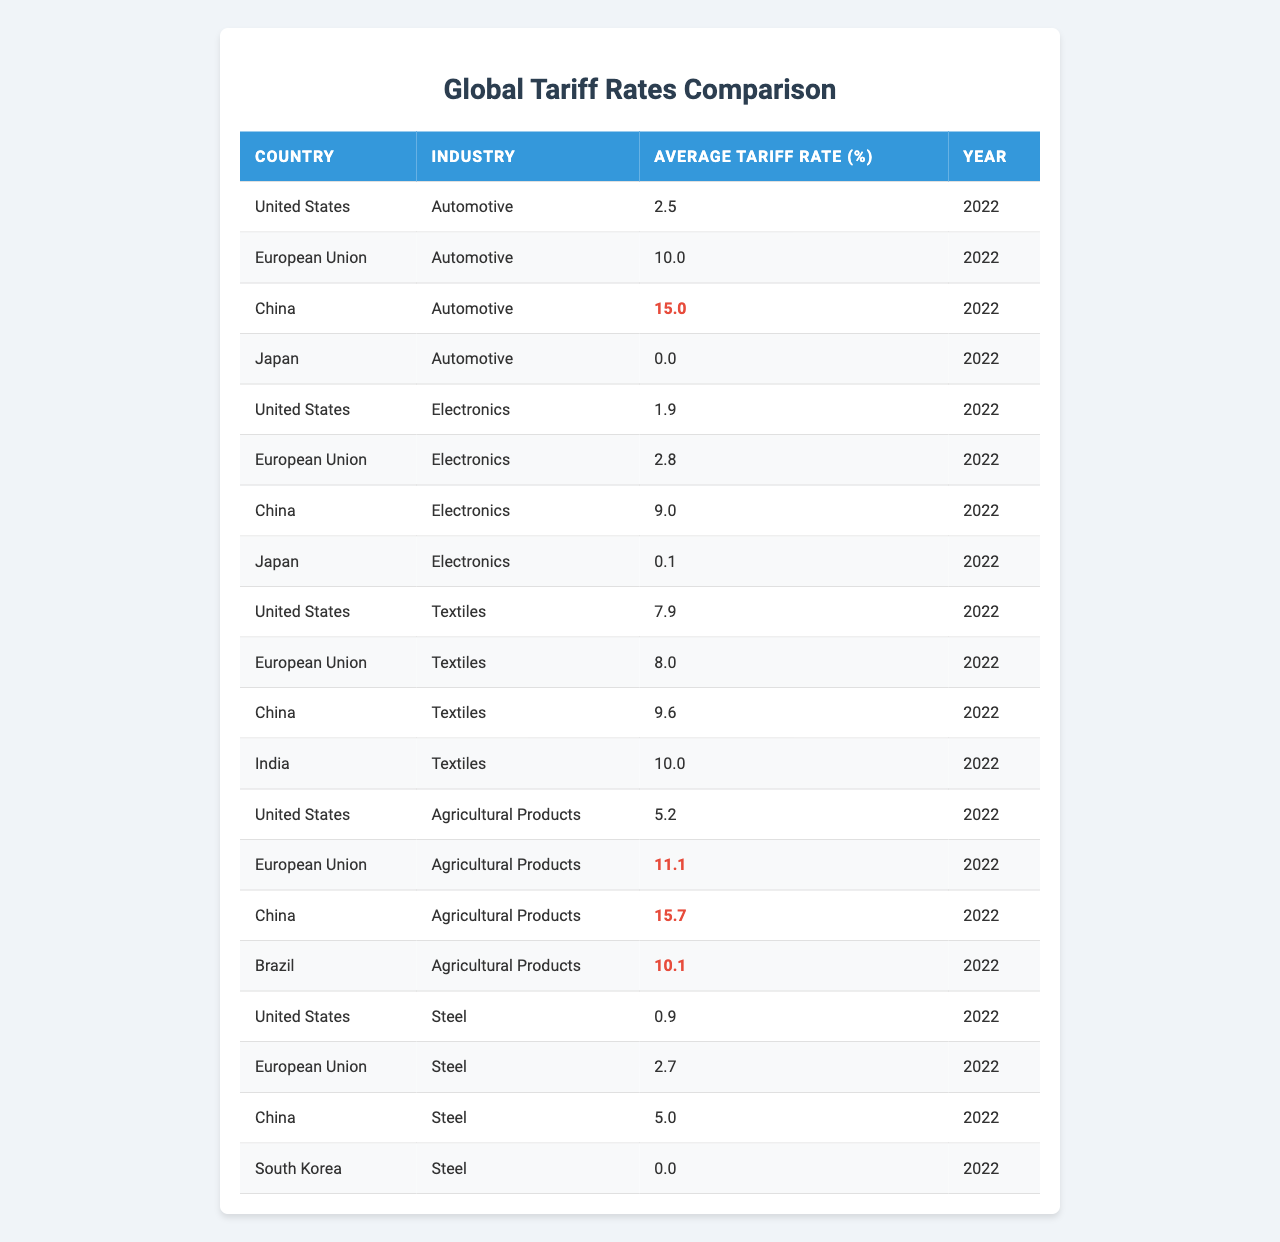What is the average tariff rate for automotive industry across these countries? The average tariff rates for the automotive industry are 2.5% (USA), 10.0% (EU), 15.0% (China), and 0.0% (Japan). To calculate the average, sum these rates: 2.5 + 10.0 + 15.0 + 0.0 = 27.5%. Divide by 4 (number of countries), resulting in an average of 27.5% / 4 = 6.875%.
Answer: 6.875% Which country has the highest tariff rate for electronics? Looking at the tariff rates for electronics, we have 1.9% (USA), 2.8% (EU), 9.0% (China), and 0.1% (Japan). The highest value here is 9.0% from China.
Answer: China Do any countries have a tariff rate of 0% for the steel industry? In the table, the tariff rates for steel are as follows: 0.9% (USA), 2.7% (EU), 5.0% (China), and 0.0% (South Korea). Since South Korea has a rate of 0.0%, the answer is yes.
Answer: Yes What is the difference in the average tariff rate for agricultural products between the EU and China? The average tariff rates for agricultural products are 11.1% (EU) and 15.7% (China). To find the difference, subtract the EU rate from the China rate: 15.7 - 11.1 = 4.6.
Answer: 4.6% Is the average tariff rate for textiles higher in the US than in Japan? The average tariff rates for textiles are 7.9% (USA) and 0.0% (Japan). Since 7.9% is greater than 0.0%, the answer is yes.
Answer: Yes Which industry has the highest tariff rate in China? In China, the tariff rates by industry are: Automotive 15.0%, Electronics 9.0%, Textiles 9.6%, and Agricultural Products 15.7%. The highest tariff rates are for Automotive and Agricultural Products at 15.0% and 15.7%, respectively, making Agricultural Products the highest.
Answer: Agricultural Products What are the total tariff rates for all industries in the United States? The tariff rates for the United States' industries are: 2.5% (Automotive), 1.9% (Electronics), 7.9% (Textiles), and 5.2% (Agricultural Products), and 0.9% (Steel). Summing these gives: 2.5 + 1.9 + 7.9 + 5.2 + 0.9 = 18.4%.
Answer: 18.4% If you combine the tariff rates for textiles from the US and EU, what is the result? The textile tariff rates are 7.9% (US) and 8.0% (EU). Adding these gives: 7.9 + 8.0 = 15.9%.
Answer: 15.9% How many countries have a tariff rate greater than 10% for agricultural products? The countries and their rates for agricultural products are: US (5.2%), EU (11.1%), China (15.7%), and Brazil (10.1%). The countries with rates above 10% are EU (11.1%), China (15.7%), and Brazil (10.1%), totaling three countries.
Answer: 3 Which country imposes the highest tariffs on the textile industry? The textile tariff rates from the countries are: 7.9% (US), 8.0% (EU), 9.6% (China), and 10.0% (India). The highest rate is imposed by India at 10.0%.
Answer: India 